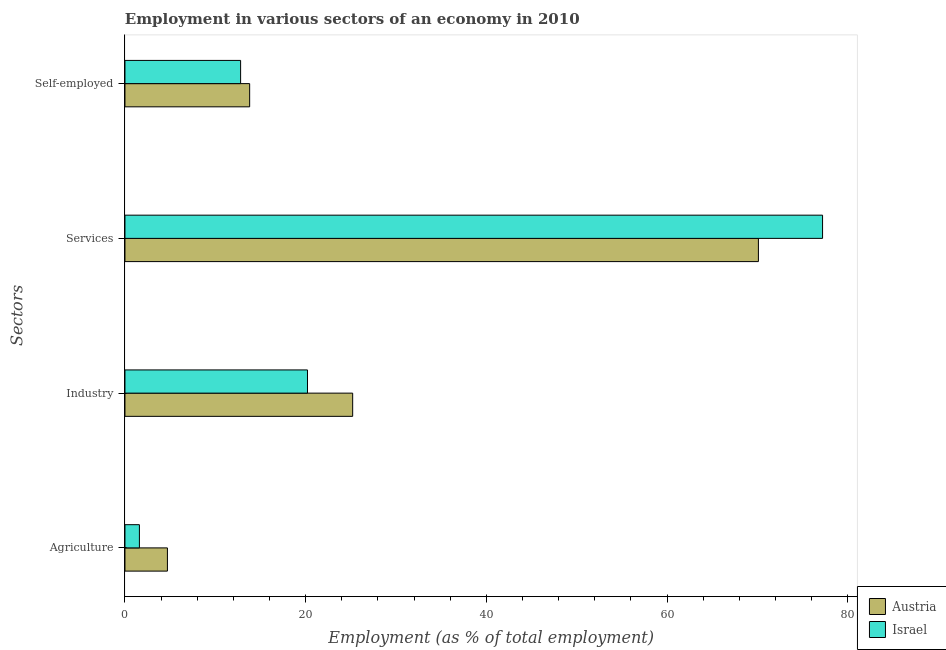How many groups of bars are there?
Ensure brevity in your answer.  4. Are the number of bars on each tick of the Y-axis equal?
Your response must be concise. Yes. How many bars are there on the 4th tick from the top?
Offer a terse response. 2. What is the label of the 2nd group of bars from the top?
Offer a very short reply. Services. What is the percentage of workers in industry in Israel?
Give a very brief answer. 20.2. Across all countries, what is the maximum percentage of workers in agriculture?
Ensure brevity in your answer.  4.7. Across all countries, what is the minimum percentage of workers in services?
Give a very brief answer. 70.1. In which country was the percentage of workers in agriculture maximum?
Your answer should be compact. Austria. What is the total percentage of workers in agriculture in the graph?
Give a very brief answer. 6.3. What is the difference between the percentage of workers in services in Austria and that in Israel?
Your answer should be very brief. -7.1. What is the difference between the percentage of workers in agriculture in Austria and the percentage of workers in industry in Israel?
Offer a very short reply. -15.5. What is the average percentage of self employed workers per country?
Offer a terse response. 13.3. What is the difference between the percentage of workers in services and percentage of workers in agriculture in Austria?
Provide a succinct answer. 65.4. What is the ratio of the percentage of workers in agriculture in Israel to that in Austria?
Your answer should be compact. 0.34. Is the percentage of workers in agriculture in Austria less than that in Israel?
Your answer should be very brief. No. What is the difference between the highest and the second highest percentage of workers in services?
Provide a short and direct response. 7.1. What is the difference between the highest and the lowest percentage of workers in industry?
Make the answer very short. 5. Is it the case that in every country, the sum of the percentage of workers in agriculture and percentage of workers in industry is greater than the percentage of workers in services?
Provide a succinct answer. No. How many legend labels are there?
Offer a very short reply. 2. What is the title of the graph?
Offer a terse response. Employment in various sectors of an economy in 2010. What is the label or title of the X-axis?
Your answer should be very brief. Employment (as % of total employment). What is the label or title of the Y-axis?
Offer a very short reply. Sectors. What is the Employment (as % of total employment) in Austria in Agriculture?
Give a very brief answer. 4.7. What is the Employment (as % of total employment) in Israel in Agriculture?
Provide a short and direct response. 1.6. What is the Employment (as % of total employment) of Austria in Industry?
Offer a terse response. 25.2. What is the Employment (as % of total employment) in Israel in Industry?
Your response must be concise. 20.2. What is the Employment (as % of total employment) in Austria in Services?
Make the answer very short. 70.1. What is the Employment (as % of total employment) in Israel in Services?
Your answer should be very brief. 77.2. What is the Employment (as % of total employment) in Austria in Self-employed?
Provide a short and direct response. 13.8. What is the Employment (as % of total employment) of Israel in Self-employed?
Offer a very short reply. 12.8. Across all Sectors, what is the maximum Employment (as % of total employment) of Austria?
Keep it short and to the point. 70.1. Across all Sectors, what is the maximum Employment (as % of total employment) of Israel?
Offer a terse response. 77.2. Across all Sectors, what is the minimum Employment (as % of total employment) of Austria?
Your answer should be compact. 4.7. Across all Sectors, what is the minimum Employment (as % of total employment) in Israel?
Provide a short and direct response. 1.6. What is the total Employment (as % of total employment) of Austria in the graph?
Provide a succinct answer. 113.8. What is the total Employment (as % of total employment) of Israel in the graph?
Keep it short and to the point. 111.8. What is the difference between the Employment (as % of total employment) in Austria in Agriculture and that in Industry?
Provide a succinct answer. -20.5. What is the difference between the Employment (as % of total employment) of Israel in Agriculture and that in Industry?
Offer a very short reply. -18.6. What is the difference between the Employment (as % of total employment) of Austria in Agriculture and that in Services?
Offer a terse response. -65.4. What is the difference between the Employment (as % of total employment) in Israel in Agriculture and that in Services?
Your response must be concise. -75.6. What is the difference between the Employment (as % of total employment) in Israel in Agriculture and that in Self-employed?
Provide a short and direct response. -11.2. What is the difference between the Employment (as % of total employment) of Austria in Industry and that in Services?
Make the answer very short. -44.9. What is the difference between the Employment (as % of total employment) of Israel in Industry and that in Services?
Provide a short and direct response. -57. What is the difference between the Employment (as % of total employment) of Austria in Industry and that in Self-employed?
Offer a terse response. 11.4. What is the difference between the Employment (as % of total employment) of Austria in Services and that in Self-employed?
Ensure brevity in your answer.  56.3. What is the difference between the Employment (as % of total employment) of Israel in Services and that in Self-employed?
Provide a succinct answer. 64.4. What is the difference between the Employment (as % of total employment) in Austria in Agriculture and the Employment (as % of total employment) in Israel in Industry?
Your answer should be very brief. -15.5. What is the difference between the Employment (as % of total employment) in Austria in Agriculture and the Employment (as % of total employment) in Israel in Services?
Your response must be concise. -72.5. What is the difference between the Employment (as % of total employment) of Austria in Agriculture and the Employment (as % of total employment) of Israel in Self-employed?
Make the answer very short. -8.1. What is the difference between the Employment (as % of total employment) of Austria in Industry and the Employment (as % of total employment) of Israel in Services?
Ensure brevity in your answer.  -52. What is the difference between the Employment (as % of total employment) in Austria in Industry and the Employment (as % of total employment) in Israel in Self-employed?
Offer a terse response. 12.4. What is the difference between the Employment (as % of total employment) in Austria in Services and the Employment (as % of total employment) in Israel in Self-employed?
Keep it short and to the point. 57.3. What is the average Employment (as % of total employment) of Austria per Sectors?
Give a very brief answer. 28.45. What is the average Employment (as % of total employment) of Israel per Sectors?
Offer a terse response. 27.95. What is the difference between the Employment (as % of total employment) in Austria and Employment (as % of total employment) in Israel in Agriculture?
Offer a very short reply. 3.1. What is the difference between the Employment (as % of total employment) of Austria and Employment (as % of total employment) of Israel in Industry?
Your answer should be very brief. 5. What is the difference between the Employment (as % of total employment) of Austria and Employment (as % of total employment) of Israel in Services?
Offer a very short reply. -7.1. What is the difference between the Employment (as % of total employment) in Austria and Employment (as % of total employment) in Israel in Self-employed?
Your response must be concise. 1. What is the ratio of the Employment (as % of total employment) in Austria in Agriculture to that in Industry?
Make the answer very short. 0.19. What is the ratio of the Employment (as % of total employment) in Israel in Agriculture to that in Industry?
Provide a succinct answer. 0.08. What is the ratio of the Employment (as % of total employment) in Austria in Agriculture to that in Services?
Your answer should be compact. 0.07. What is the ratio of the Employment (as % of total employment) of Israel in Agriculture to that in Services?
Give a very brief answer. 0.02. What is the ratio of the Employment (as % of total employment) in Austria in Agriculture to that in Self-employed?
Make the answer very short. 0.34. What is the ratio of the Employment (as % of total employment) in Israel in Agriculture to that in Self-employed?
Offer a terse response. 0.12. What is the ratio of the Employment (as % of total employment) of Austria in Industry to that in Services?
Make the answer very short. 0.36. What is the ratio of the Employment (as % of total employment) of Israel in Industry to that in Services?
Provide a succinct answer. 0.26. What is the ratio of the Employment (as % of total employment) of Austria in Industry to that in Self-employed?
Your answer should be compact. 1.83. What is the ratio of the Employment (as % of total employment) in Israel in Industry to that in Self-employed?
Keep it short and to the point. 1.58. What is the ratio of the Employment (as % of total employment) of Austria in Services to that in Self-employed?
Provide a succinct answer. 5.08. What is the ratio of the Employment (as % of total employment) of Israel in Services to that in Self-employed?
Give a very brief answer. 6.03. What is the difference between the highest and the second highest Employment (as % of total employment) in Austria?
Make the answer very short. 44.9. What is the difference between the highest and the second highest Employment (as % of total employment) in Israel?
Offer a very short reply. 57. What is the difference between the highest and the lowest Employment (as % of total employment) of Austria?
Provide a short and direct response. 65.4. What is the difference between the highest and the lowest Employment (as % of total employment) in Israel?
Your response must be concise. 75.6. 